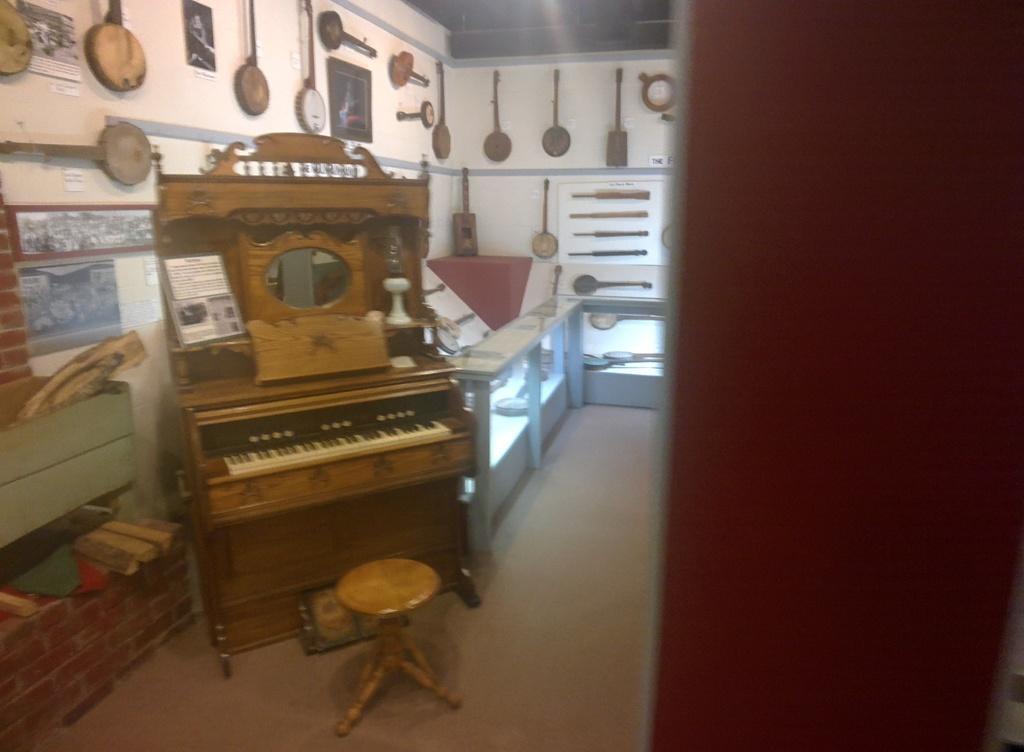Describe this image in one or two sentences. This picture shows a piano and a stool here. In the background, there are some musical instruments attached to the wall here. 